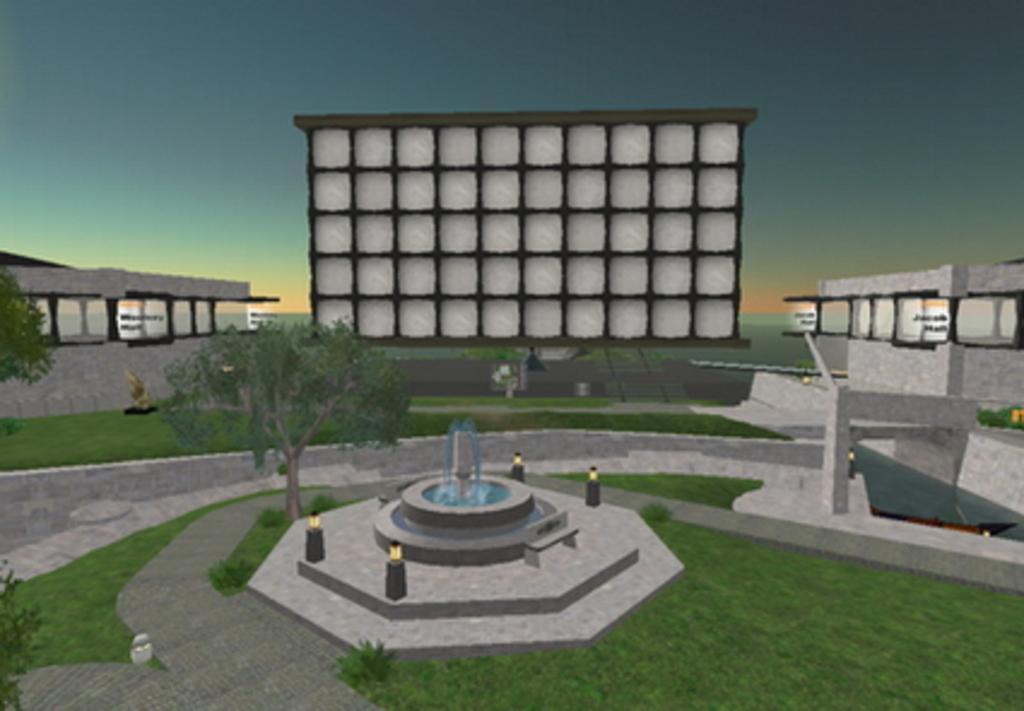Can you describe this image briefly? This is a graphical image where we can see there are tree, buildings and grass along with fountain. 